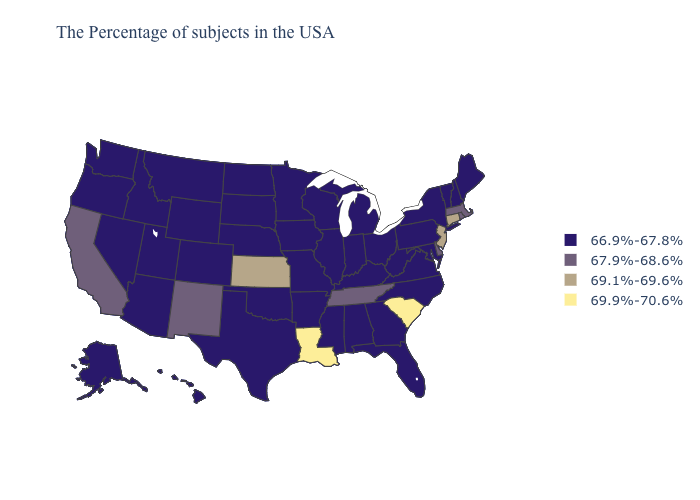Name the states that have a value in the range 69.9%-70.6%?
Short answer required. South Carolina, Louisiana. What is the value of Utah?
Keep it brief. 66.9%-67.8%. Among the states that border Texas , which have the lowest value?
Quick response, please. Arkansas, Oklahoma. What is the highest value in states that border Oklahoma?
Concise answer only. 69.1%-69.6%. Among the states that border Iowa , which have the lowest value?
Short answer required. Wisconsin, Illinois, Missouri, Minnesota, Nebraska, South Dakota. Name the states that have a value in the range 69.1%-69.6%?
Write a very short answer. Connecticut, New Jersey, Kansas. What is the value of Rhode Island?
Write a very short answer. 67.9%-68.6%. Does the map have missing data?
Quick response, please. No. What is the value of Missouri?
Answer briefly. 66.9%-67.8%. Name the states that have a value in the range 69.1%-69.6%?
Keep it brief. Connecticut, New Jersey, Kansas. Which states hav the highest value in the South?
Be succinct. South Carolina, Louisiana. What is the value of Illinois?
Short answer required. 66.9%-67.8%. Among the states that border Colorado , which have the lowest value?
Short answer required. Nebraska, Oklahoma, Wyoming, Utah, Arizona. Name the states that have a value in the range 69.1%-69.6%?
Keep it brief. Connecticut, New Jersey, Kansas. Name the states that have a value in the range 69.9%-70.6%?
Keep it brief. South Carolina, Louisiana. 